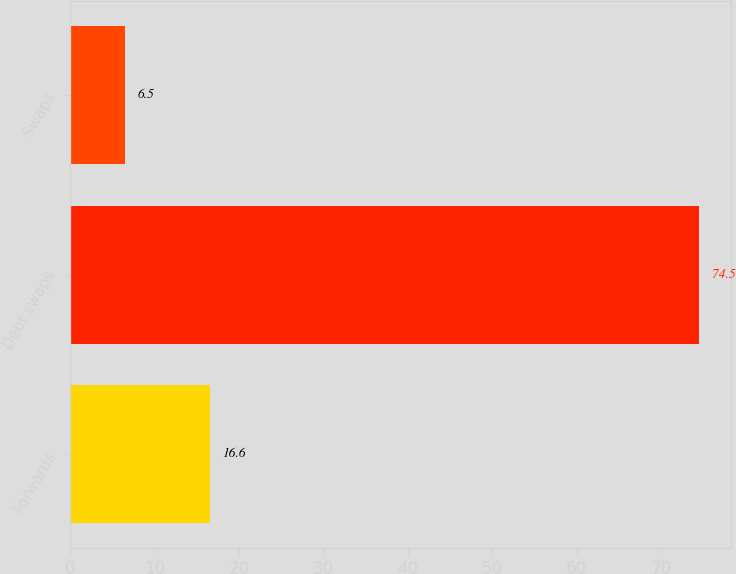Convert chart to OTSL. <chart><loc_0><loc_0><loc_500><loc_500><bar_chart><fcel>Forwards<fcel>Debt swaps<fcel>Swaps<nl><fcel>16.6<fcel>74.5<fcel>6.5<nl></chart> 